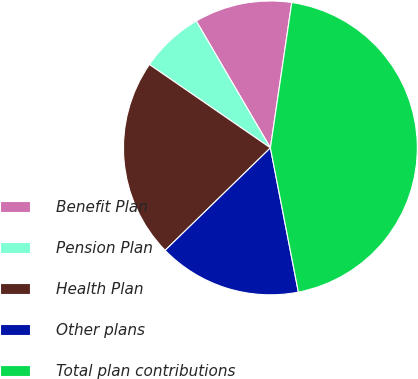Convert chart to OTSL. <chart><loc_0><loc_0><loc_500><loc_500><pie_chart><fcel>Benefit Plan<fcel>Pension Plan<fcel>Health Plan<fcel>Other plans<fcel>Total plan contributions<nl><fcel>10.74%<fcel>6.98%<fcel>21.89%<fcel>15.76%<fcel>44.63%<nl></chart> 